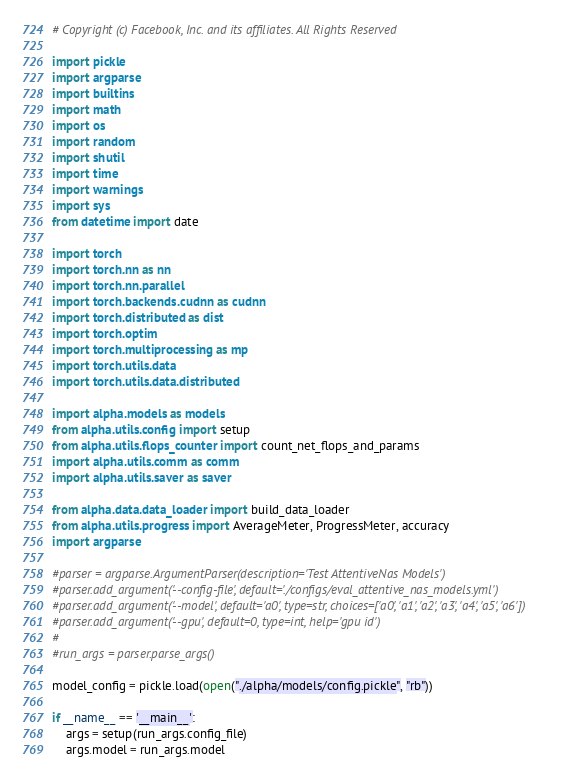Convert code to text. <code><loc_0><loc_0><loc_500><loc_500><_Python_># Copyright (c) Facebook, Inc. and its affiliates. All Rights Reserved

import pickle
import argparse
import builtins
import math
import os
import random
import shutil
import time
import warnings
import sys
from datetime import date

import torch
import torch.nn as nn
import torch.nn.parallel
import torch.backends.cudnn as cudnn
import torch.distributed as dist
import torch.optim
import torch.multiprocessing as mp
import torch.utils.data
import torch.utils.data.distributed

import alpha.models as models
from alpha.utils.config import setup
from alpha.utils.flops_counter import count_net_flops_and_params
import alpha.utils.comm as comm
import alpha.utils.saver as saver

from alpha.data.data_loader import build_data_loader
from alpha.utils.progress import AverageMeter, ProgressMeter, accuracy
import argparse

#parser = argparse.ArgumentParser(description='Test AttentiveNas Models')
#parser.add_argument('--config-file', default='./configs/eval_attentive_nas_models.yml')
#parser.add_argument('--model', default='a0', type=str, choices=['a0', 'a1', 'a2', 'a3', 'a4', 'a5', 'a6'])
#parser.add_argument('--gpu', default=0, type=int, help='gpu id')
#
#run_args = parser.parse_args()

model_config = pickle.load(open("./alpha/models/config.pickle", "rb"))

if __name__ == '__main__':
    args = setup(run_args.config_file)
    args.model = run_args.model</code> 